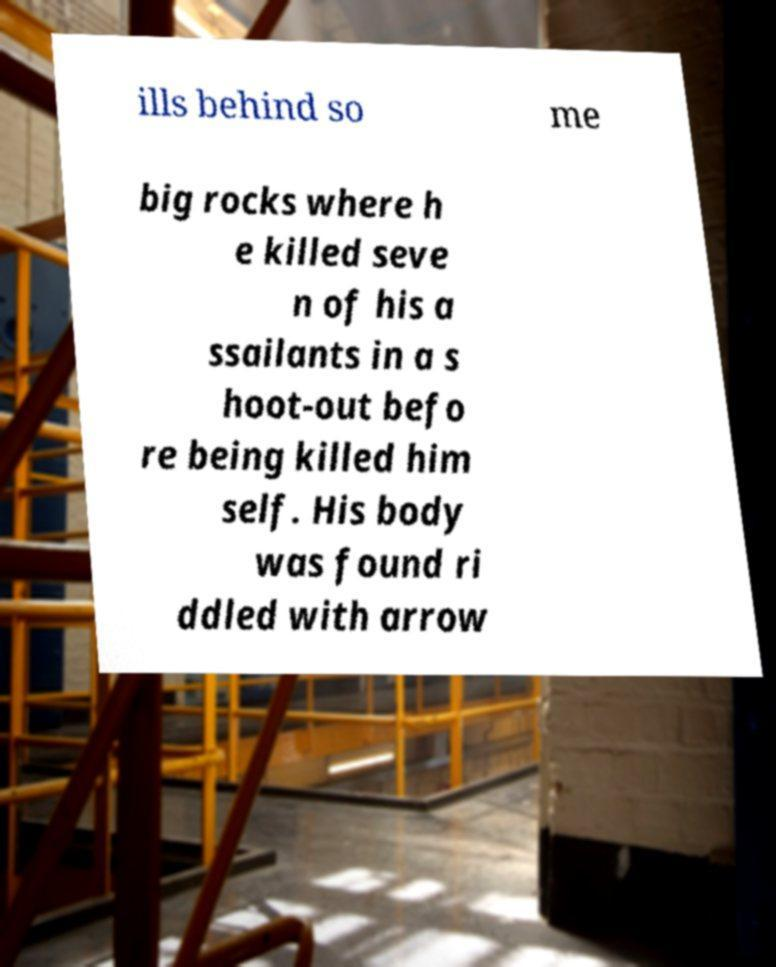Please read and relay the text visible in this image. What does it say? ills behind so me big rocks where h e killed seve n of his a ssailants in a s hoot-out befo re being killed him self. His body was found ri ddled with arrow 